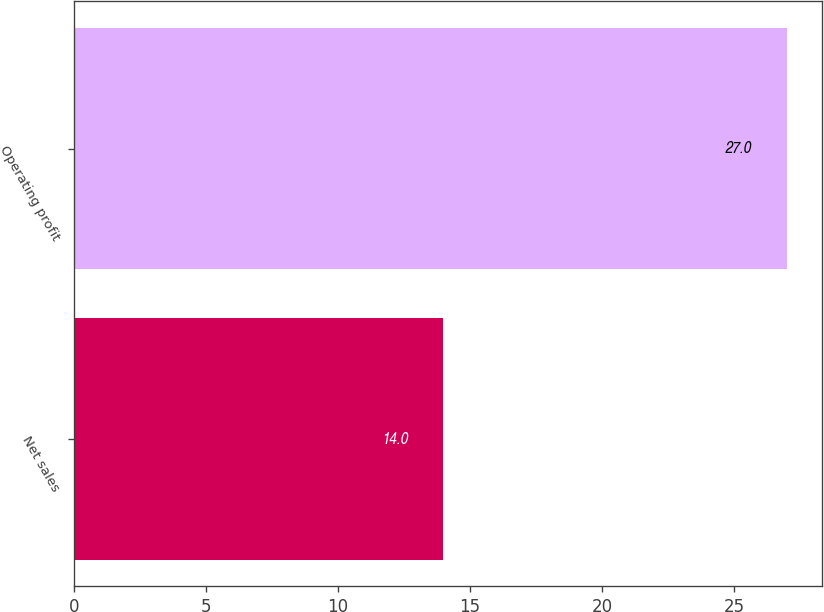Convert chart. <chart><loc_0><loc_0><loc_500><loc_500><bar_chart><fcel>Net sales<fcel>Operating profit<nl><fcel>14<fcel>27<nl></chart> 